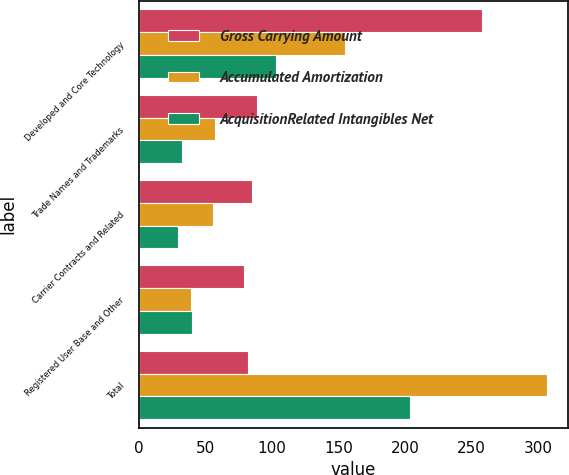Convert chart to OTSL. <chart><loc_0><loc_0><loc_500><loc_500><stacked_bar_chart><ecel><fcel>Developed and Core Technology<fcel>Trade Names and Trademarks<fcel>Carrier Contracts and Related<fcel>Registered User Base and Other<fcel>Total<nl><fcel>Gross Carrying Amount<fcel>258<fcel>89<fcel>85<fcel>79<fcel>82<nl><fcel>Accumulated Amortization<fcel>155<fcel>57<fcel>56<fcel>39<fcel>307<nl><fcel>AcquisitionRelated Intangibles Net<fcel>103<fcel>32<fcel>29<fcel>40<fcel>204<nl></chart> 